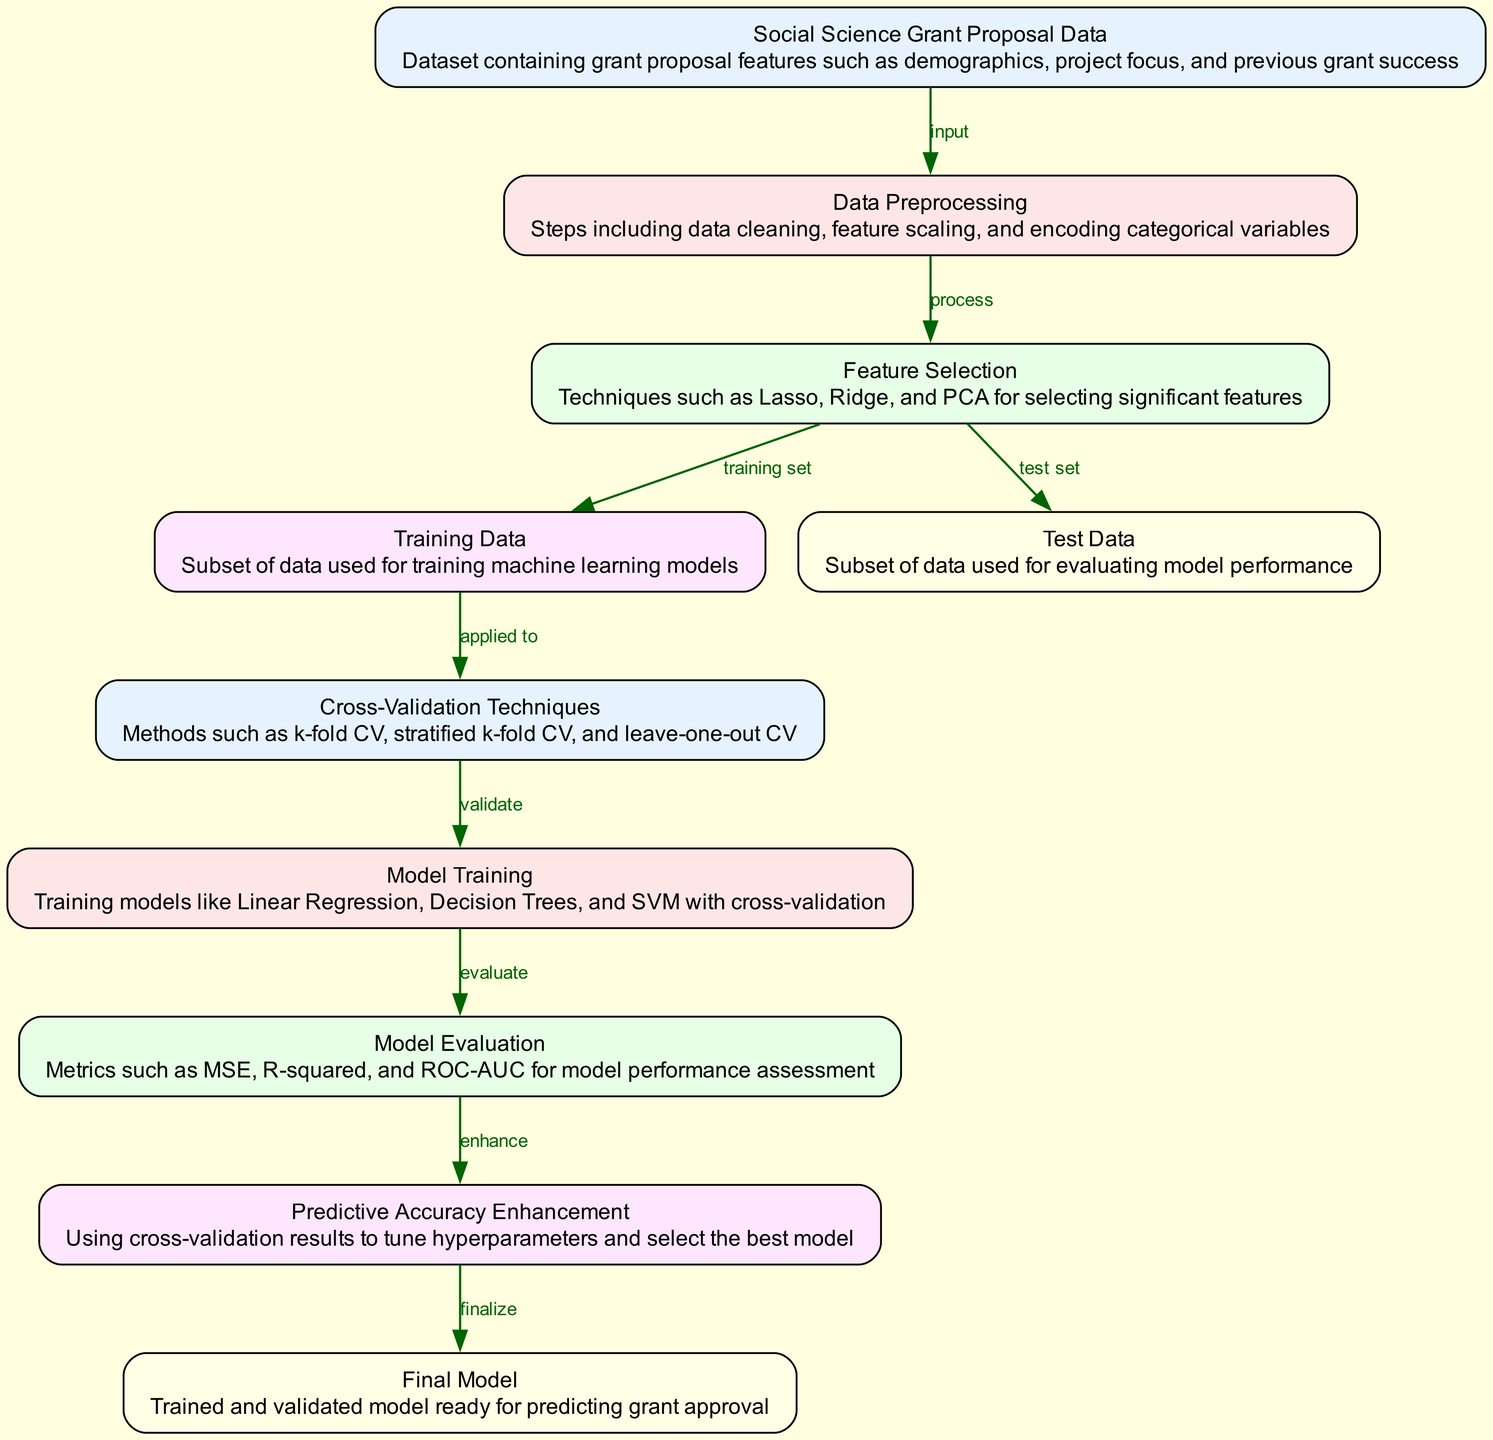What is the first node in the diagram? The first node listed in the diagram is "Social Science Grant Proposal Data," which serves as the input to the entire process.
Answer: Social Science Grant Proposal Data How many nodes are present in this diagram? By counting all the listed nodes in the diagram, there are a total of ten nodes representing different steps in the process.
Answer: 10 Which node represents the evaluation process? The node labeled "Model Evaluation" describes the step where various metrics are utilized to assess model performance.
Answer: Model Evaluation What technique is applied in the "Training Data" node? The "Training Data" node indicates that it is a subset of data used for training machine learning models following the feature selection step.
Answer: Subset of data for training What is the relationship between "Cross-Validation Techniques" and "Model Training"? The "Cross-Validation Techniques" node is indicated to validate the "Model Training" node, demonstrating that various validation methods are essential for training models properly.
Answer: Validate What metrics are used in the "Model Evaluation"? The "Model Evaluation" node lists metrics such as MSE, R-squared, and ROC-AUC, which are commonly used to assess model performance.
Answer: MSE, R-squared, ROC-AUC Which node comes after "Predictive Accuracy Enhancement"? The "Final Model" node follows the "Predictive Accuracy Enhancement" node, indicating the completion of the model development process.
Answer: Final Model Which method is used for feature selection? The "Feature Selection" node mentions techniques such as Lasso, Ridge, and PCA, which are commonly employed for selecting significant features in the dataset.
Answer: Lasso, Ridge, PCA What does the "Test Data" node represent? The "Test Data" node is defined as the subset of data used specifically for evaluating model performance post-training.
Answer: Subset for evaluating performance 